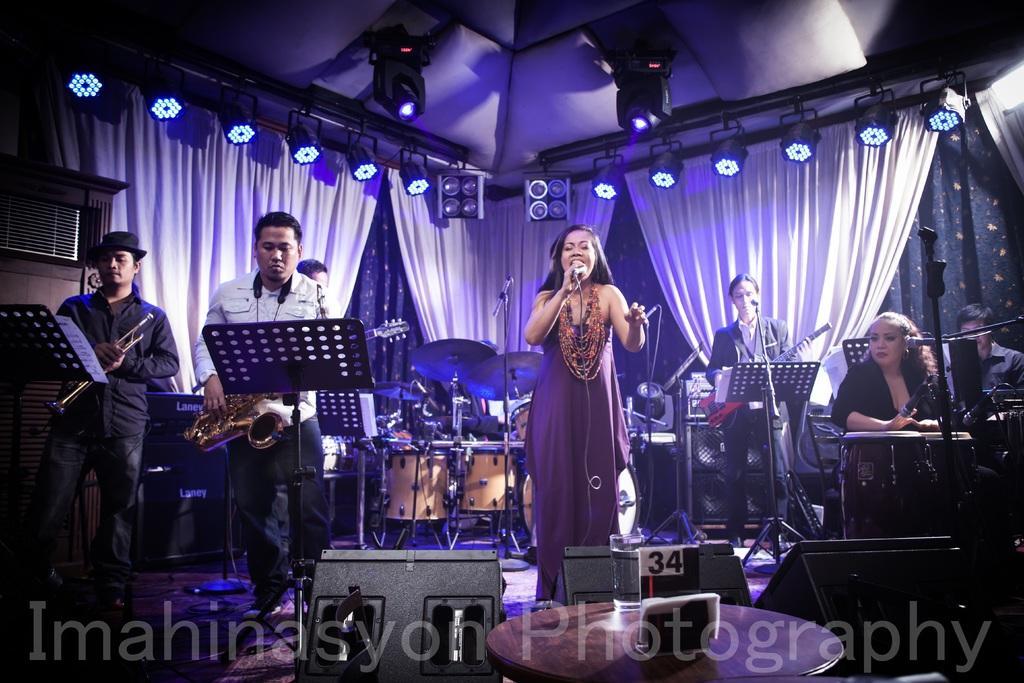Can you describe this image briefly? In the image I can see some people playing some musical instruments and also I can see a girl who is holding the mic and behind there are some other things and some lights to the roof. 